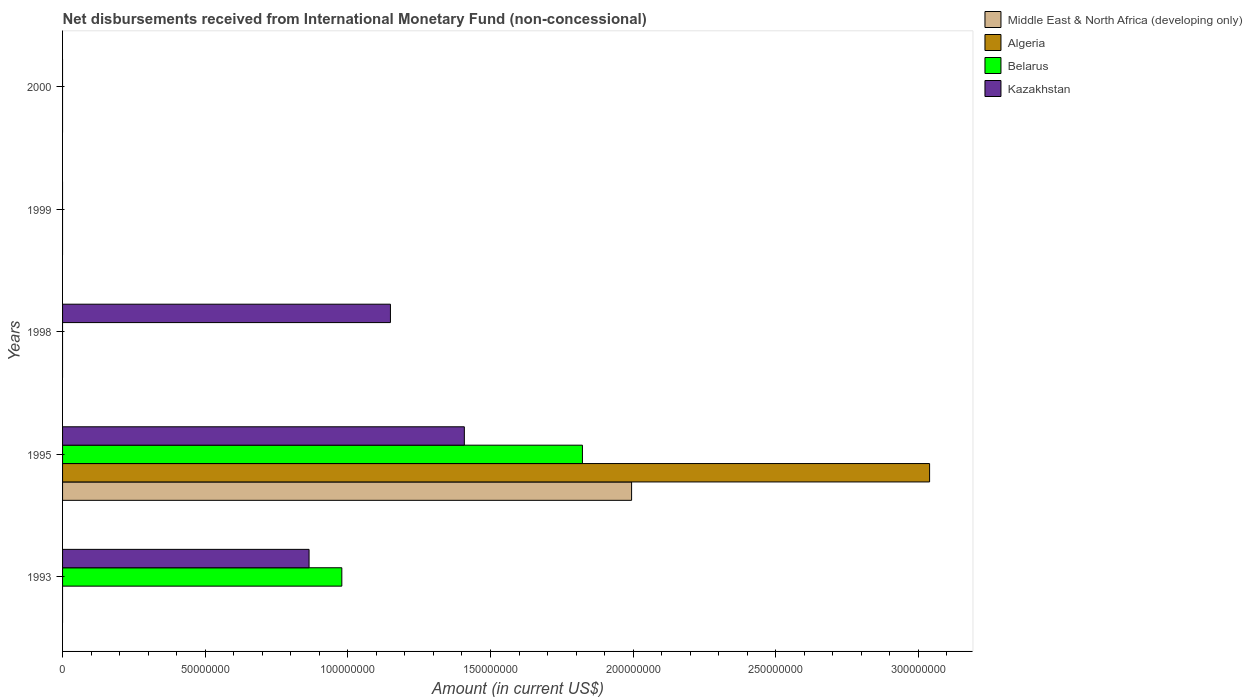How many different coloured bars are there?
Your answer should be compact. 4. Are the number of bars on each tick of the Y-axis equal?
Keep it short and to the point. No. What is the amount of disbursements received from International Monetary Fund in Middle East & North Africa (developing only) in 1995?
Your response must be concise. 1.99e+08. Across all years, what is the maximum amount of disbursements received from International Monetary Fund in Algeria?
Keep it short and to the point. 3.04e+08. What is the total amount of disbursements received from International Monetary Fund in Algeria in the graph?
Offer a terse response. 3.04e+08. What is the average amount of disbursements received from International Monetary Fund in Middle East & North Africa (developing only) per year?
Ensure brevity in your answer.  3.99e+07. In the year 1993, what is the difference between the amount of disbursements received from International Monetary Fund in Kazakhstan and amount of disbursements received from International Monetary Fund in Belarus?
Make the answer very short. -1.15e+07. What is the ratio of the amount of disbursements received from International Monetary Fund in Kazakhstan in 1995 to that in 1998?
Provide a succinct answer. 1.23. What is the difference between the highest and the second highest amount of disbursements received from International Monetary Fund in Kazakhstan?
Your answer should be compact. 2.59e+07. What is the difference between the highest and the lowest amount of disbursements received from International Monetary Fund in Kazakhstan?
Make the answer very short. 1.41e+08. In how many years, is the amount of disbursements received from International Monetary Fund in Algeria greater than the average amount of disbursements received from International Monetary Fund in Algeria taken over all years?
Offer a terse response. 1. Is it the case that in every year, the sum of the amount of disbursements received from International Monetary Fund in Algeria and amount of disbursements received from International Monetary Fund in Kazakhstan is greater than the sum of amount of disbursements received from International Monetary Fund in Belarus and amount of disbursements received from International Monetary Fund in Middle East & North Africa (developing only)?
Your response must be concise. No. What is the difference between two consecutive major ticks on the X-axis?
Your answer should be very brief. 5.00e+07. Are the values on the major ticks of X-axis written in scientific E-notation?
Provide a succinct answer. No. Does the graph contain grids?
Make the answer very short. No. Where does the legend appear in the graph?
Give a very brief answer. Top right. How many legend labels are there?
Offer a very short reply. 4. What is the title of the graph?
Offer a very short reply. Net disbursements received from International Monetary Fund (non-concessional). What is the Amount (in current US$) in Middle East & North Africa (developing only) in 1993?
Ensure brevity in your answer.  0. What is the Amount (in current US$) in Algeria in 1993?
Offer a very short reply. 0. What is the Amount (in current US$) in Belarus in 1993?
Keep it short and to the point. 9.79e+07. What is the Amount (in current US$) in Kazakhstan in 1993?
Keep it short and to the point. 8.64e+07. What is the Amount (in current US$) in Middle East & North Africa (developing only) in 1995?
Offer a very short reply. 1.99e+08. What is the Amount (in current US$) of Algeria in 1995?
Provide a short and direct response. 3.04e+08. What is the Amount (in current US$) of Belarus in 1995?
Ensure brevity in your answer.  1.82e+08. What is the Amount (in current US$) in Kazakhstan in 1995?
Provide a short and direct response. 1.41e+08. What is the Amount (in current US$) of Algeria in 1998?
Offer a terse response. 0. What is the Amount (in current US$) of Belarus in 1998?
Your answer should be very brief. 0. What is the Amount (in current US$) of Kazakhstan in 1998?
Offer a very short reply. 1.15e+08. What is the Amount (in current US$) of Algeria in 1999?
Your answer should be compact. 0. What is the Amount (in current US$) in Belarus in 1999?
Your answer should be compact. 0. What is the Amount (in current US$) of Kazakhstan in 1999?
Your answer should be compact. 0. What is the Amount (in current US$) in Algeria in 2000?
Keep it short and to the point. 0. What is the Amount (in current US$) of Kazakhstan in 2000?
Your response must be concise. 0. Across all years, what is the maximum Amount (in current US$) of Middle East & North Africa (developing only)?
Your answer should be compact. 1.99e+08. Across all years, what is the maximum Amount (in current US$) in Algeria?
Your answer should be compact. 3.04e+08. Across all years, what is the maximum Amount (in current US$) of Belarus?
Provide a short and direct response. 1.82e+08. Across all years, what is the maximum Amount (in current US$) in Kazakhstan?
Provide a short and direct response. 1.41e+08. Across all years, what is the minimum Amount (in current US$) of Middle East & North Africa (developing only)?
Offer a terse response. 0. Across all years, what is the minimum Amount (in current US$) of Algeria?
Keep it short and to the point. 0. Across all years, what is the minimum Amount (in current US$) of Belarus?
Your answer should be very brief. 0. What is the total Amount (in current US$) of Middle East & North Africa (developing only) in the graph?
Provide a short and direct response. 1.99e+08. What is the total Amount (in current US$) of Algeria in the graph?
Your response must be concise. 3.04e+08. What is the total Amount (in current US$) in Belarus in the graph?
Ensure brevity in your answer.  2.80e+08. What is the total Amount (in current US$) in Kazakhstan in the graph?
Your answer should be very brief. 3.42e+08. What is the difference between the Amount (in current US$) of Belarus in 1993 and that in 1995?
Provide a succinct answer. -8.43e+07. What is the difference between the Amount (in current US$) in Kazakhstan in 1993 and that in 1995?
Provide a succinct answer. -5.44e+07. What is the difference between the Amount (in current US$) in Kazakhstan in 1993 and that in 1998?
Make the answer very short. -2.85e+07. What is the difference between the Amount (in current US$) of Kazakhstan in 1995 and that in 1998?
Your response must be concise. 2.59e+07. What is the difference between the Amount (in current US$) of Belarus in 1993 and the Amount (in current US$) of Kazakhstan in 1995?
Provide a succinct answer. -4.29e+07. What is the difference between the Amount (in current US$) in Belarus in 1993 and the Amount (in current US$) in Kazakhstan in 1998?
Ensure brevity in your answer.  -1.70e+07. What is the difference between the Amount (in current US$) in Middle East & North Africa (developing only) in 1995 and the Amount (in current US$) in Kazakhstan in 1998?
Provide a succinct answer. 8.45e+07. What is the difference between the Amount (in current US$) of Algeria in 1995 and the Amount (in current US$) of Kazakhstan in 1998?
Make the answer very short. 1.89e+08. What is the difference between the Amount (in current US$) of Belarus in 1995 and the Amount (in current US$) of Kazakhstan in 1998?
Provide a short and direct response. 6.73e+07. What is the average Amount (in current US$) of Middle East & North Africa (developing only) per year?
Provide a succinct answer. 3.99e+07. What is the average Amount (in current US$) in Algeria per year?
Your answer should be very brief. 6.08e+07. What is the average Amount (in current US$) of Belarus per year?
Make the answer very short. 5.60e+07. What is the average Amount (in current US$) in Kazakhstan per year?
Offer a very short reply. 6.84e+07. In the year 1993, what is the difference between the Amount (in current US$) in Belarus and Amount (in current US$) in Kazakhstan?
Your answer should be very brief. 1.15e+07. In the year 1995, what is the difference between the Amount (in current US$) in Middle East & North Africa (developing only) and Amount (in current US$) in Algeria?
Your response must be concise. -1.04e+08. In the year 1995, what is the difference between the Amount (in current US$) in Middle East & North Africa (developing only) and Amount (in current US$) in Belarus?
Keep it short and to the point. 1.72e+07. In the year 1995, what is the difference between the Amount (in current US$) of Middle East & North Africa (developing only) and Amount (in current US$) of Kazakhstan?
Offer a terse response. 5.86e+07. In the year 1995, what is the difference between the Amount (in current US$) of Algeria and Amount (in current US$) of Belarus?
Your answer should be compact. 1.22e+08. In the year 1995, what is the difference between the Amount (in current US$) of Algeria and Amount (in current US$) of Kazakhstan?
Provide a short and direct response. 1.63e+08. In the year 1995, what is the difference between the Amount (in current US$) in Belarus and Amount (in current US$) in Kazakhstan?
Ensure brevity in your answer.  4.14e+07. What is the ratio of the Amount (in current US$) in Belarus in 1993 to that in 1995?
Provide a succinct answer. 0.54. What is the ratio of the Amount (in current US$) of Kazakhstan in 1993 to that in 1995?
Make the answer very short. 0.61. What is the ratio of the Amount (in current US$) in Kazakhstan in 1993 to that in 1998?
Give a very brief answer. 0.75. What is the ratio of the Amount (in current US$) in Kazakhstan in 1995 to that in 1998?
Provide a short and direct response. 1.23. What is the difference between the highest and the second highest Amount (in current US$) in Kazakhstan?
Your answer should be compact. 2.59e+07. What is the difference between the highest and the lowest Amount (in current US$) in Middle East & North Africa (developing only)?
Offer a very short reply. 1.99e+08. What is the difference between the highest and the lowest Amount (in current US$) of Algeria?
Your answer should be compact. 3.04e+08. What is the difference between the highest and the lowest Amount (in current US$) in Belarus?
Make the answer very short. 1.82e+08. What is the difference between the highest and the lowest Amount (in current US$) in Kazakhstan?
Keep it short and to the point. 1.41e+08. 